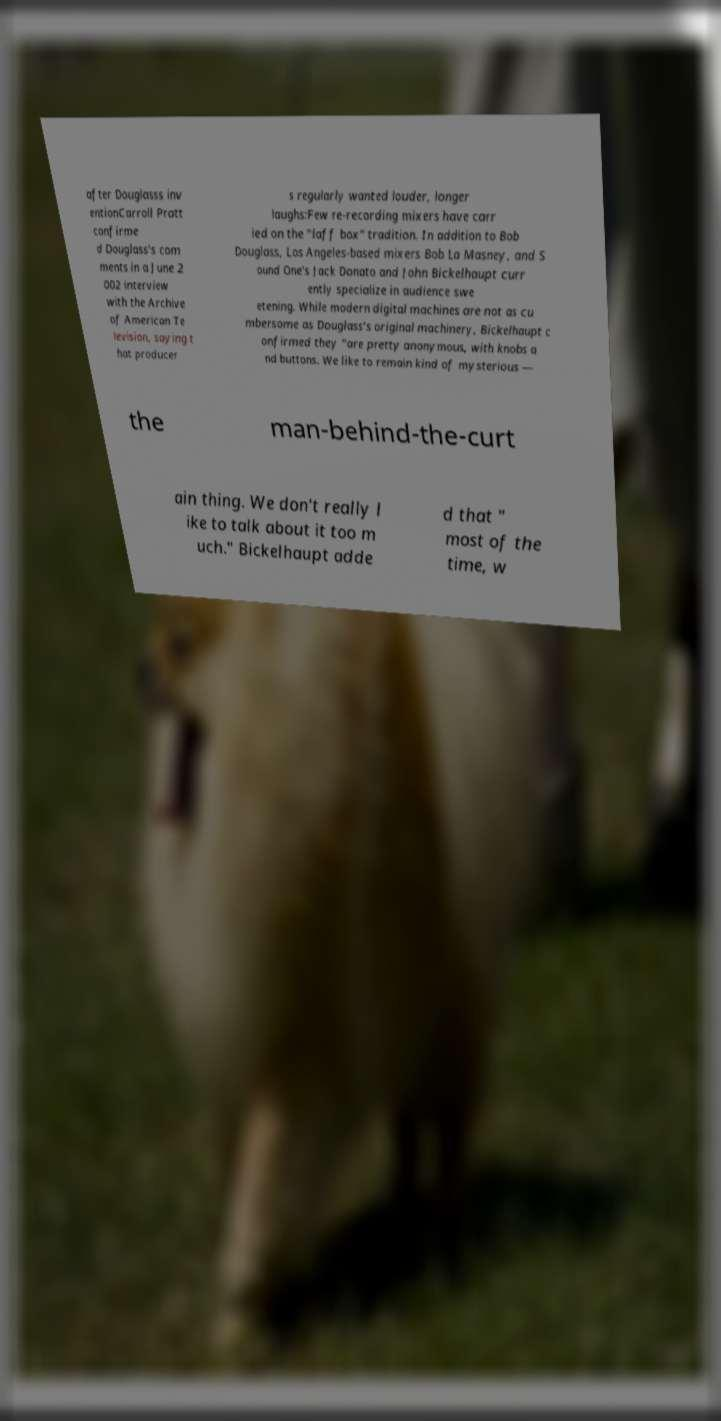Please read and relay the text visible in this image. What does it say? after Douglasss inv entionCarroll Pratt confirme d Douglass's com ments in a June 2 002 interview with the Archive of American Te levision, saying t hat producer s regularly wanted louder, longer laughs:Few re-recording mixers have carr ied on the "laff box" tradition. In addition to Bob Douglass, Los Angeles-based mixers Bob La Masney, and S ound One's Jack Donato and John Bickelhaupt curr ently specialize in audience swe etening. While modern digital machines are not as cu mbersome as Douglass's original machinery, Bickelhaupt c onfirmed they "are pretty anonymous, with knobs a nd buttons. We like to remain kind of mysterious — the man-behind-the-curt ain thing. We don't really l ike to talk about it too m uch." Bickelhaupt adde d that " most of the time, w 